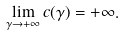<formula> <loc_0><loc_0><loc_500><loc_500>\lim _ { \gamma \to + \infty } c ( \gamma ) = + \infty .</formula> 